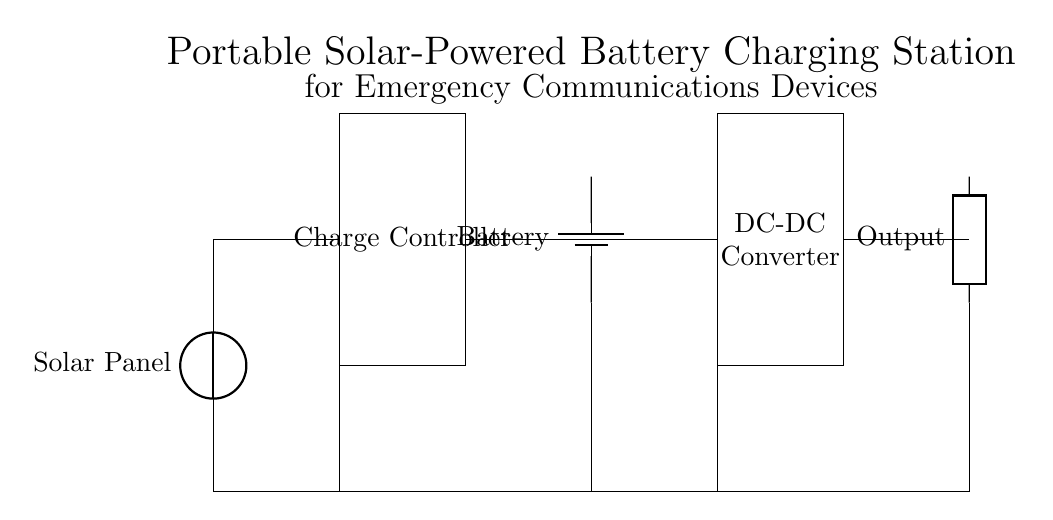What is the main power source for this charging station? The main power source is the solar panel, which generates electricity from sunlight to charge the battery.
Answer: Solar panel What component is responsible for regulating the voltage and current to the battery? The charge controller is the component that manages the voltage and current coming from the solar panel to ensure the battery is charged safely and efficiently.
Answer: Charge controller How many components are directly connected to the battery? The battery is directly connected to two components: the charge controller and the DC-DC converter, which manage the input and output of energy to and from the battery.
Answer: Two What type of output does this circuit provide? The output is a generic output that can be used to connect emergency communications devices, providing the necessary power for their operation.
Answer: Generic output What function does the DC-DC converter serve in this circuit? The DC-DC converter adjusts the voltage levels to ensure that the output voltage is suitable for the devices being charged, which is essential for compatibility and efficiency.
Answer: Adjusts voltage How does the solar panel connect within the circuit? The solar panel connects to the charge controller, which is positioned at the top of the circuit and serves as the initial component receiving solar energy for conversion and storage.
Answer: To the charge controller 